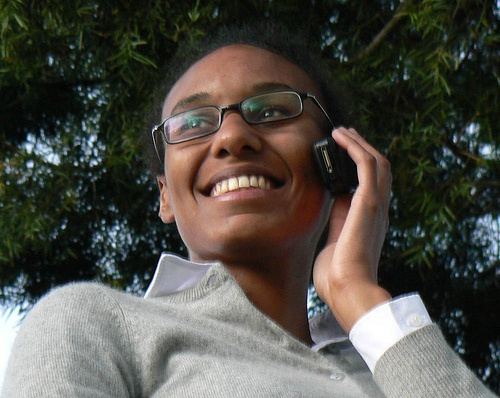Describe the objects in this image and their specific colors. I can see people in darkgreen, darkgray, black, lightgray, and maroon tones and cell phone in darkgreen, black, gray, and maroon tones in this image. 